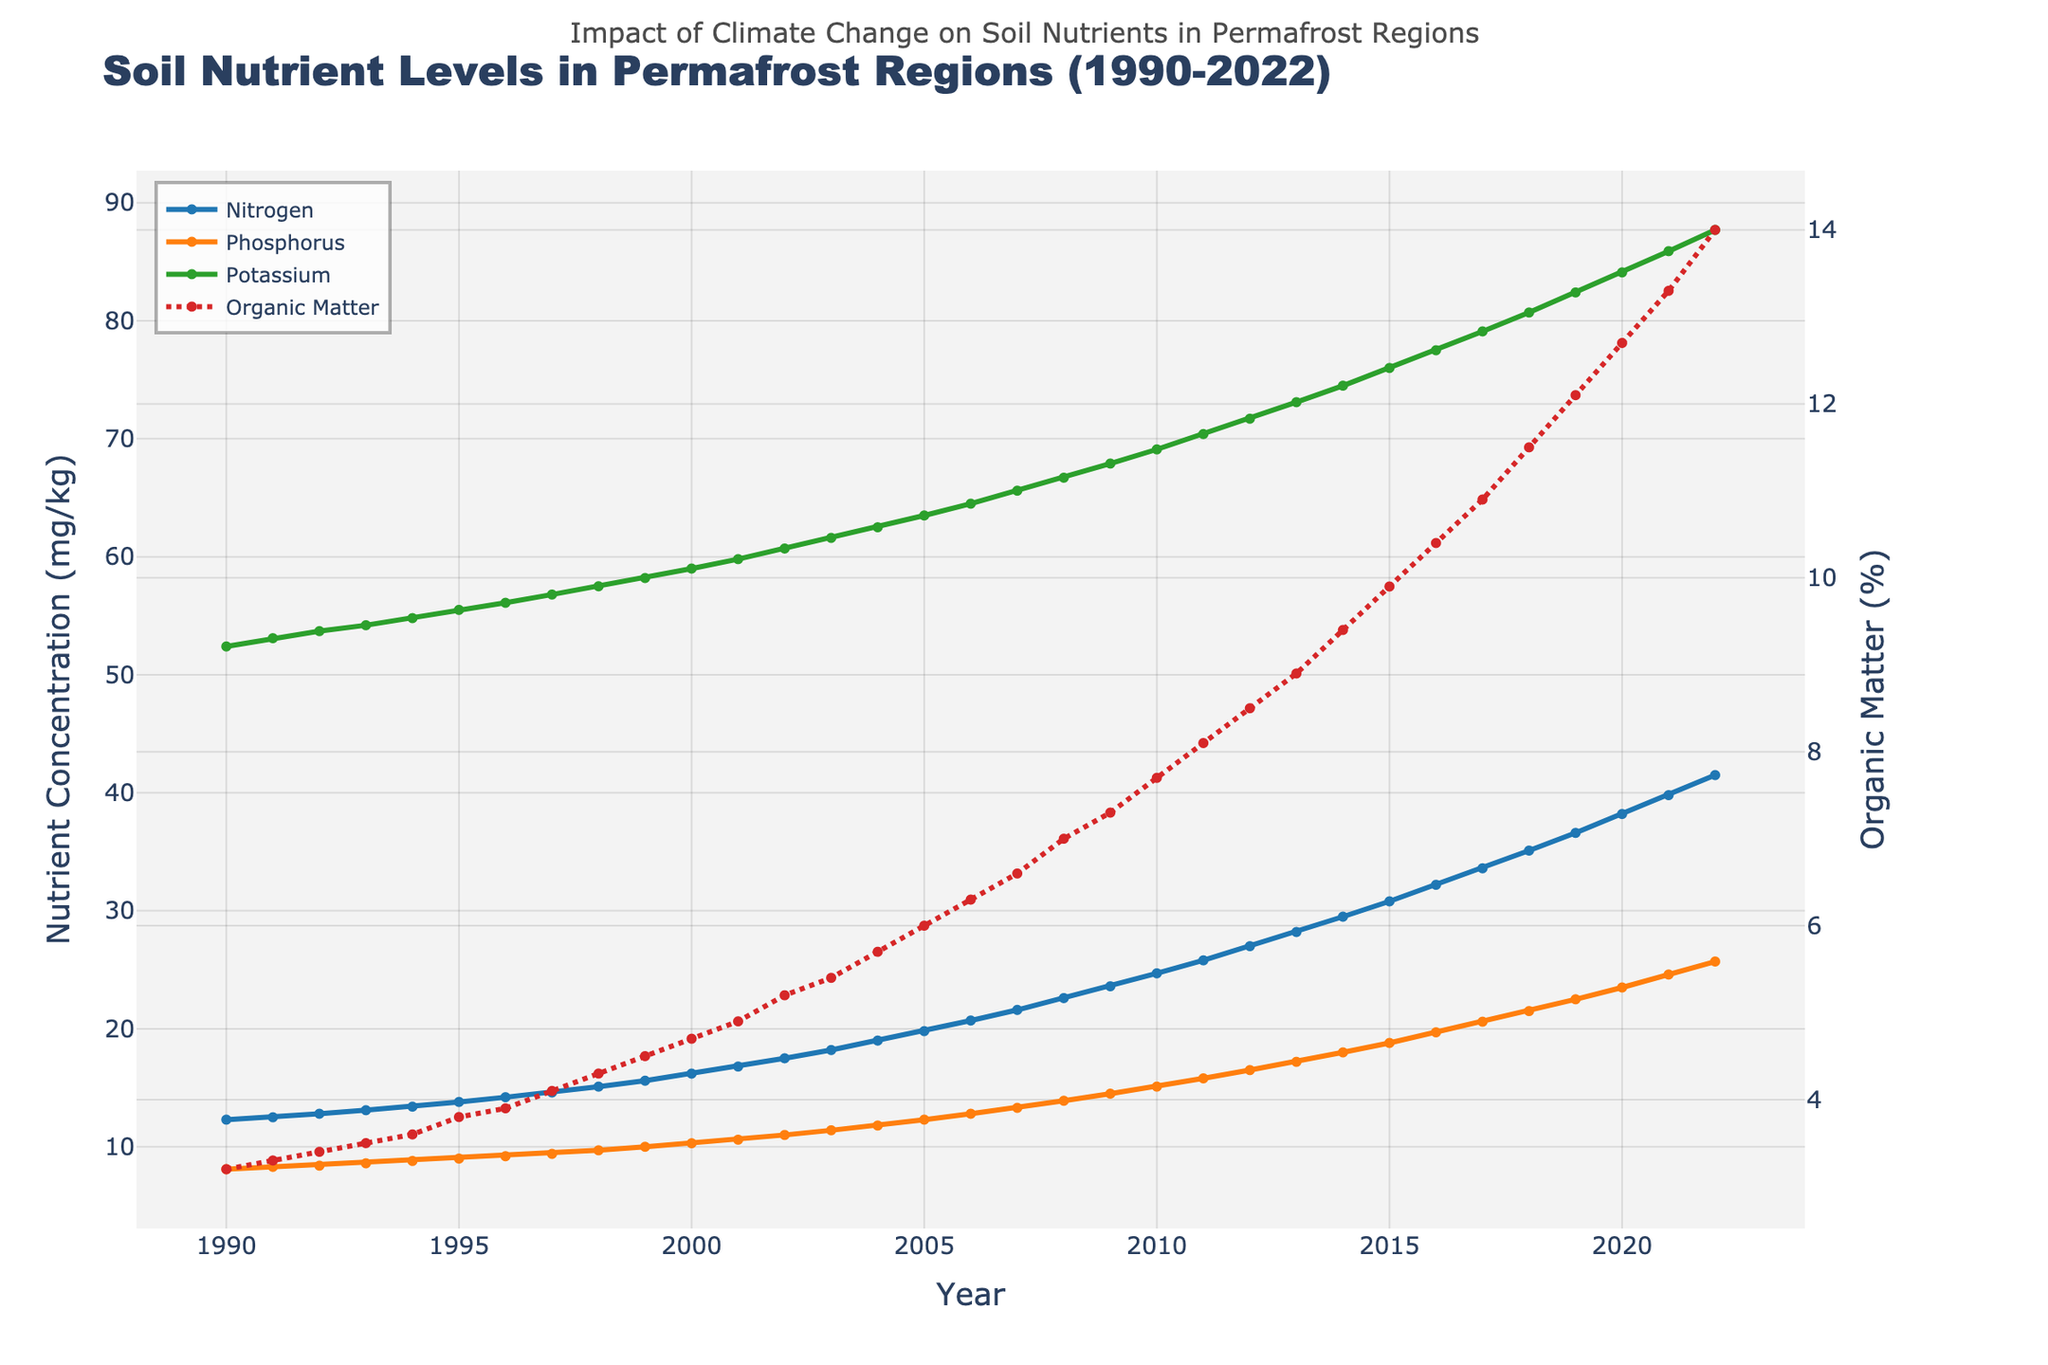1. How has the nitrogen level changed from 1990 to 2022? The nitrogen level in 1990 was 12.3 mg/kg and increased to 41.5 mg/kg by 2022. The difference is 41.5 - 12.3 = 29.2 mg/kg.
Answer: 29.2 mg/kg 2. In which year did the organic matter percentage reach 10%? By examining the organic matter levels on the secondary y-axis, we find that 10% was surpassed in 2016.
Answer: 2016 3. Which nutrient shows the highest increase over the 32-year period? By observing the slopes of the lines, nitrogen increased from 12.3 mg/kg to 41.5 mg/kg (29.2 mg/kg), phosphorus from 8.1 mg/kg to 25.7 mg/kg (17.6 mg/kg), and potassium from 52.4 mg/kg to 87.7 mg/kg (35.3 mg/kg). The highest increase is in potassium.
Answer: Potassium 4. Compare the organic matter percentage in 2000 and 2020. Which year had a higher value, and by how much? In 2000, the organic matter percentage was 4.7%, while in 2020, it was 12.7%. Therefore, the increase was 12.7% - 4.7% = 8%.
Answer: 2020; 8% 5. How many years did it take for the phosphorus level to double from its 1990 value? The 1990 phosphorus level was 8.1 mg/kg. It doubled to around 16.2 mg/kg. This value was reached between 2011 and 2012. From 1990 to 2012 is 22 years.
Answer: 22 years 6. What is the average annual increase in potassium levels from 1990 to 2022? The potassium level increased from 52.4 mg/kg to 87.7 mg/kg over 32 years. The total increase is 87.7 - 52.4 = 35.3 mg/kg. The average annual increase is 35.3 mg/kg ÷ 32 ≈ 1.10 mg/kg per year.
Answer: ≈ 1.10 mg/kg per year 7. By how much did the organic matter percentage increase from 2015 to 2022? From the figure, organic matter increased from 9.9% in 2015 to 14.0% in 2022. The increase is 14.0% - 9.9% = 4.1%.
Answer: 4.1% 8. In which years did phosphorus show a constant annual increase of 0.7 mg/kg? Observing the phosphorus levels, a constant annual increase of 0.7 mg/kg is seen from 2017 (20.6 mg/kg) to 2018 (21.5 mg/kg), and from 2018 (21.5 mg/kg) to 2019 (22.5 mg/kg).
Answer: 2017-2019 9. Compare the rate of increase of nitrogen and organic matter from 2000 to 2010. Which one increased faster? Nitrogen increased from 16.2 mg/kg to 24.7 mg/kg (8.5 mg/kg increase) and organic matter from 4.7% to 7.7% (3.0% increase) between 2000 and 2010. Comparing the challenges in visual slope rates, nitrogen increased faster.
Answer: Nitrogen 10. Between which consecutive years did potassium levels experience the highest increase? By examining the steepest rise in the potassium plot, the highest increase of 1.7 mg/kg occurred between 2018 (80.7 mg/kg) and 2019 (82.4 mg/kg).
Answer: 2018-2019 